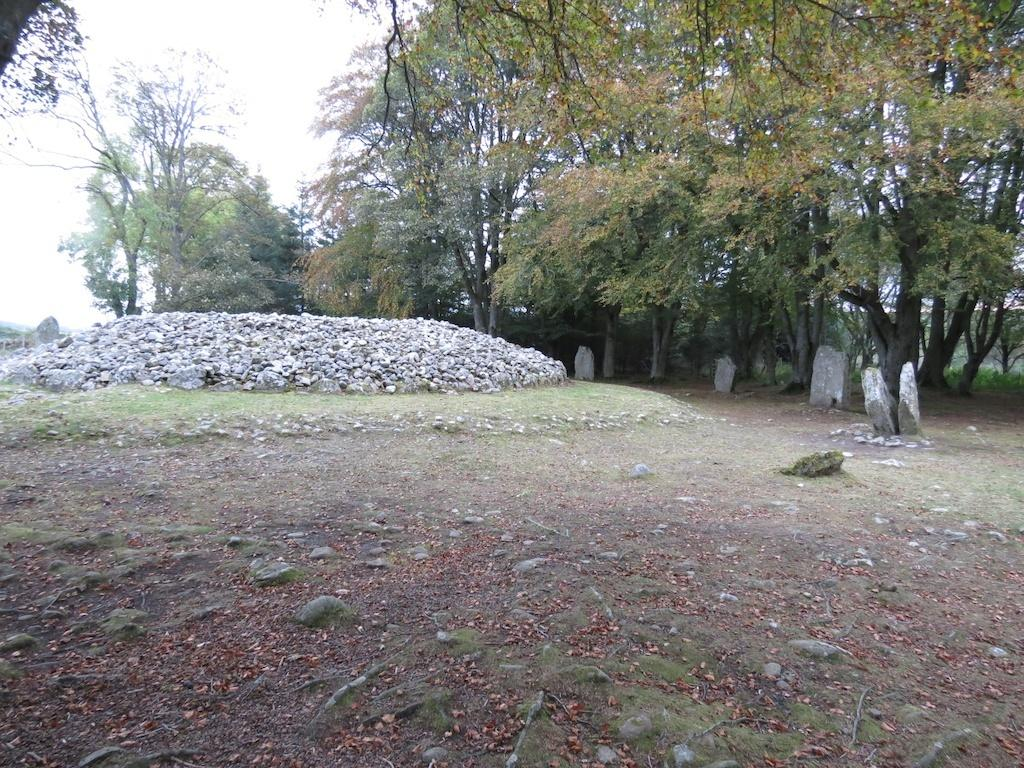Where was the picture taken? The picture was clicked outside. What can be seen in the center of the image? There are rocks, green grass, trees, and other objects in the center of the image. What is visible in the background of the image? The sky is visible in the background of the image. What type of street can be seen in the image? There is no street visible in the image; it features rocks, green grass, trees, and other objects in the center, with the sky visible in the background. 